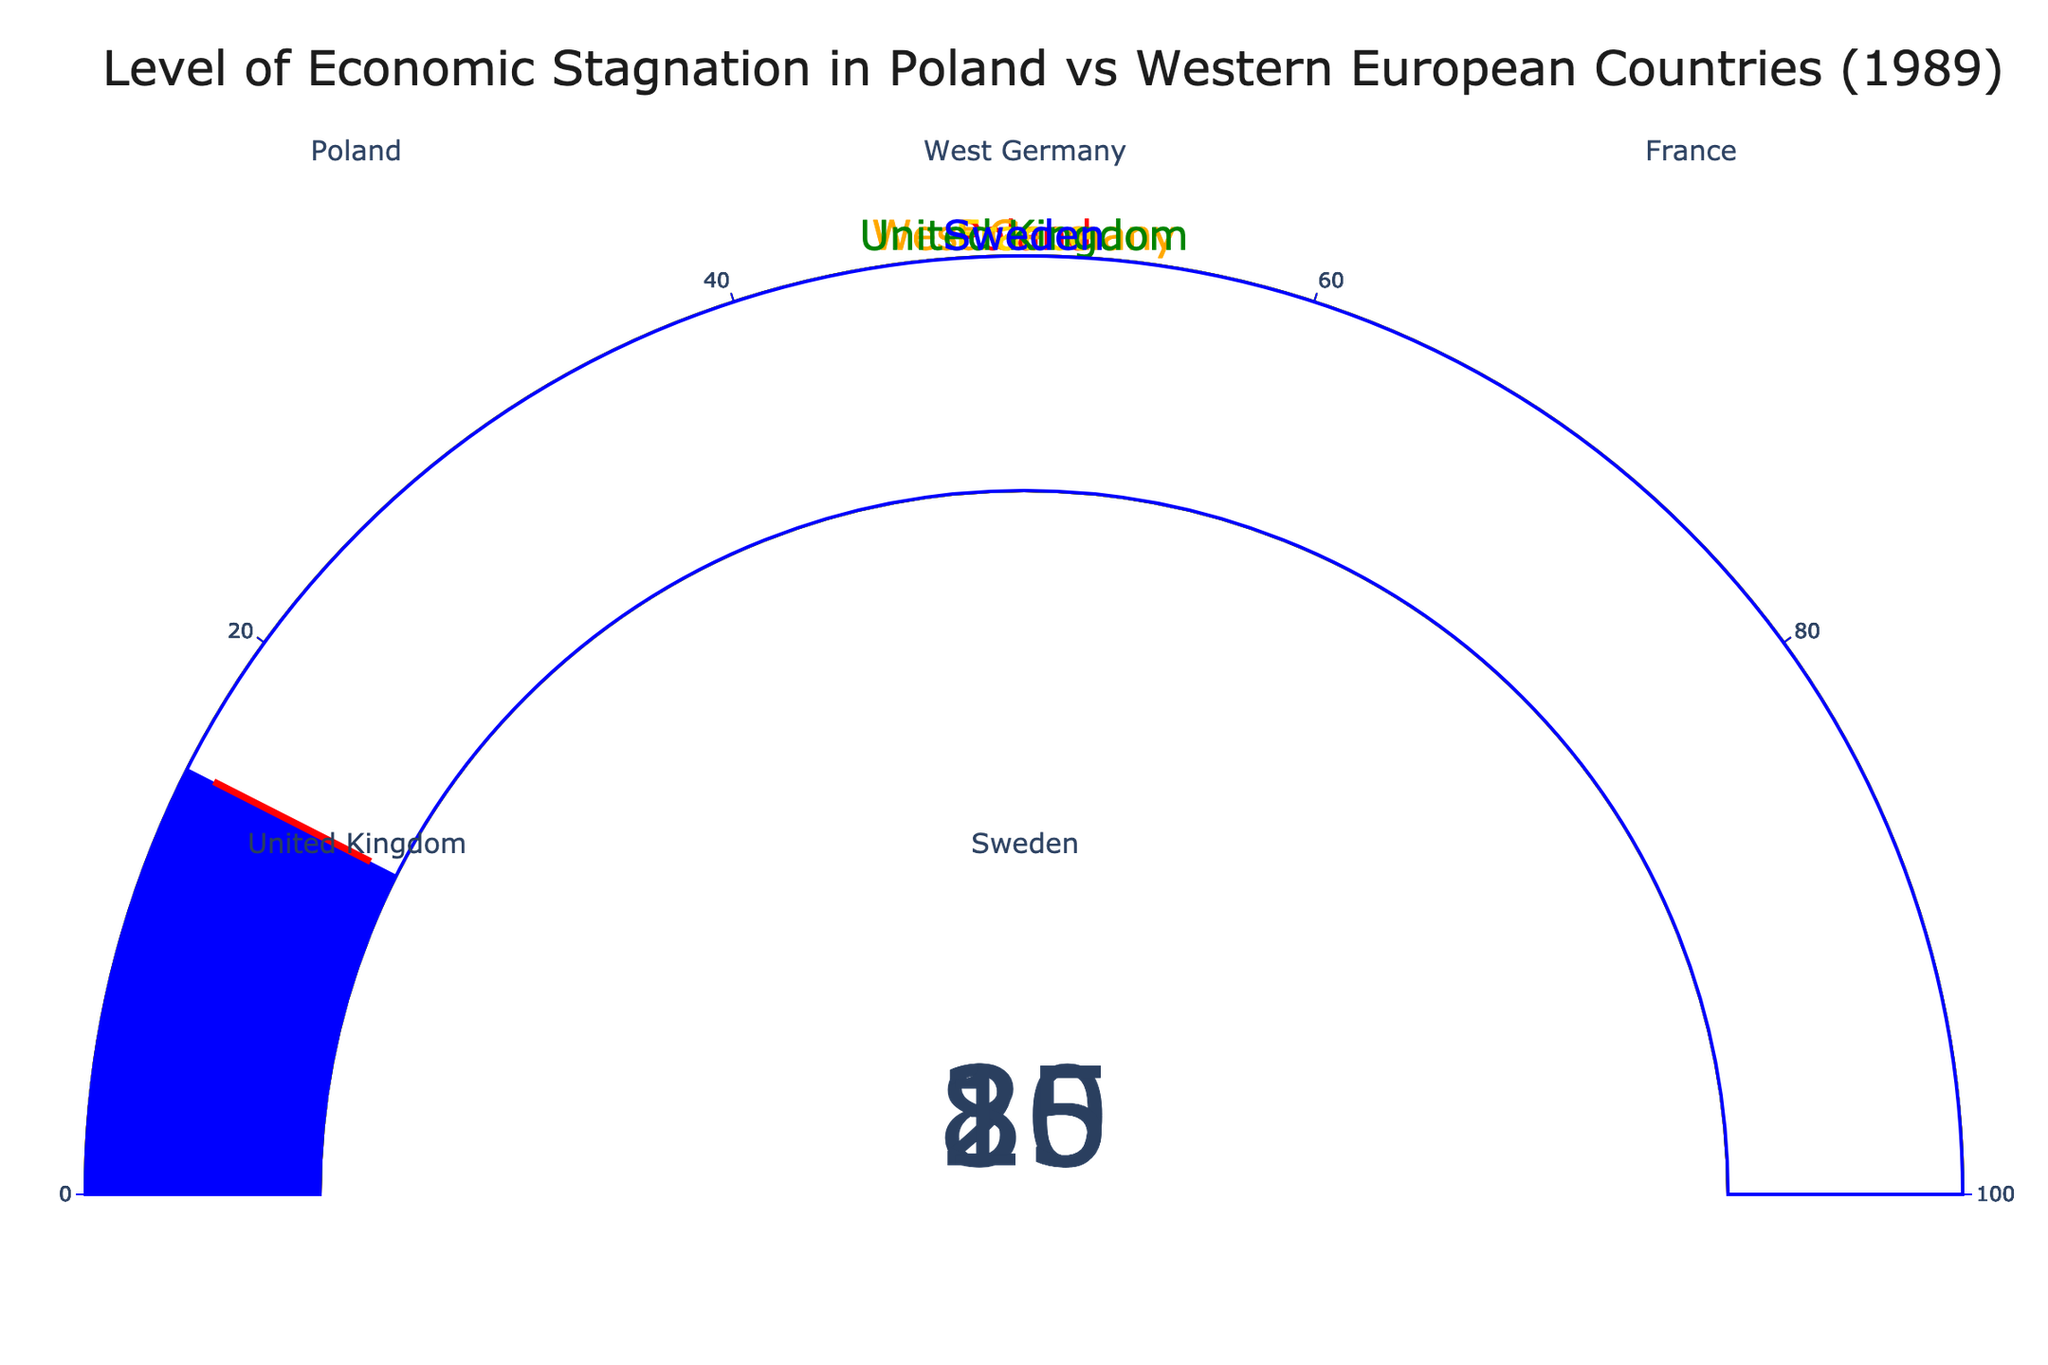What is the level of economic stagnation in Poland by 1989? The gauge labeled "Poland" indicates an economic stagnation level of 85.
Answer: 85 Which Western European country had the highest level of economic stagnation by 1989? The gauges show values for West Germany (20), France (25), United Kingdom (30), and Sweden (15). The highest value among these is the United Kingdom with a level of 30.
Answer: United Kingdom How much higher is Poland's economic stagnation level compared to Sweden's? Poland's level is 85 and Sweden's is 15. The difference is 85 - 15 = 70.
Answer: 70 What is the average economic stagnation level of the Western European countries shown? The levels for the Western European countries are West Germany (20), France (25), United Kingdom (30), and Sweden (15). The sum is 20 + 25 + 30 + 15 = 90. The average is 90 / 4 = 22.5.
Answer: 22.5 Is there a significant difference between the economic stagnation levels of Poland and West Germany? Poland's level is 85 and West Germany's is 20. The difference is 85 - 20 = 65, which indicates a significant difference.
Answer: Yes Among the countries listed, which one has the lowest economic stagnation level by 1989? The gauges show values for West Germany (20), France (25), United Kingdom (30), Sweden (15), and Poland (85). The lowest value is from Sweden with a level of 15.
Answer: Sweden By how much does Poland's economic stagnation level exceed the average of the Western European countries? The average economic stagnation level of the Western European countries is 22.5. Poland's level is 85. The difference is 85 - 22.5 = 62.5.
Answer: 62.5 If we combine the economic stagnation levels of France and the United Kingdom, how does that compare to Poland's level? France's level is 25 and the United Kingdom's is 30. Combined, they total 25 + 30 = 55. Poland's level is 85. So, 85 - 55 = 30, meaning Poland's level is 30 points higher.
Answer: Poland's is 30 points higher Which country experienced half the economic stagnation level of Poland by 1989? Poland's level is 85. Half of 85 is 42.5. Among the Western European countries, none have a value exactly at 42.5, but the United Kingdom's level of 30 is the closest to half.
Answer: United Kingdom What is the combined economic stagnation level of all the countries in the figure? The levels for all the countries are West Germany (20), France (25), United Kingdom (30), Sweden (15), and Poland (85). The sum is 20 + 25 + 30 + 15 + 85 = 175.
Answer: 175 